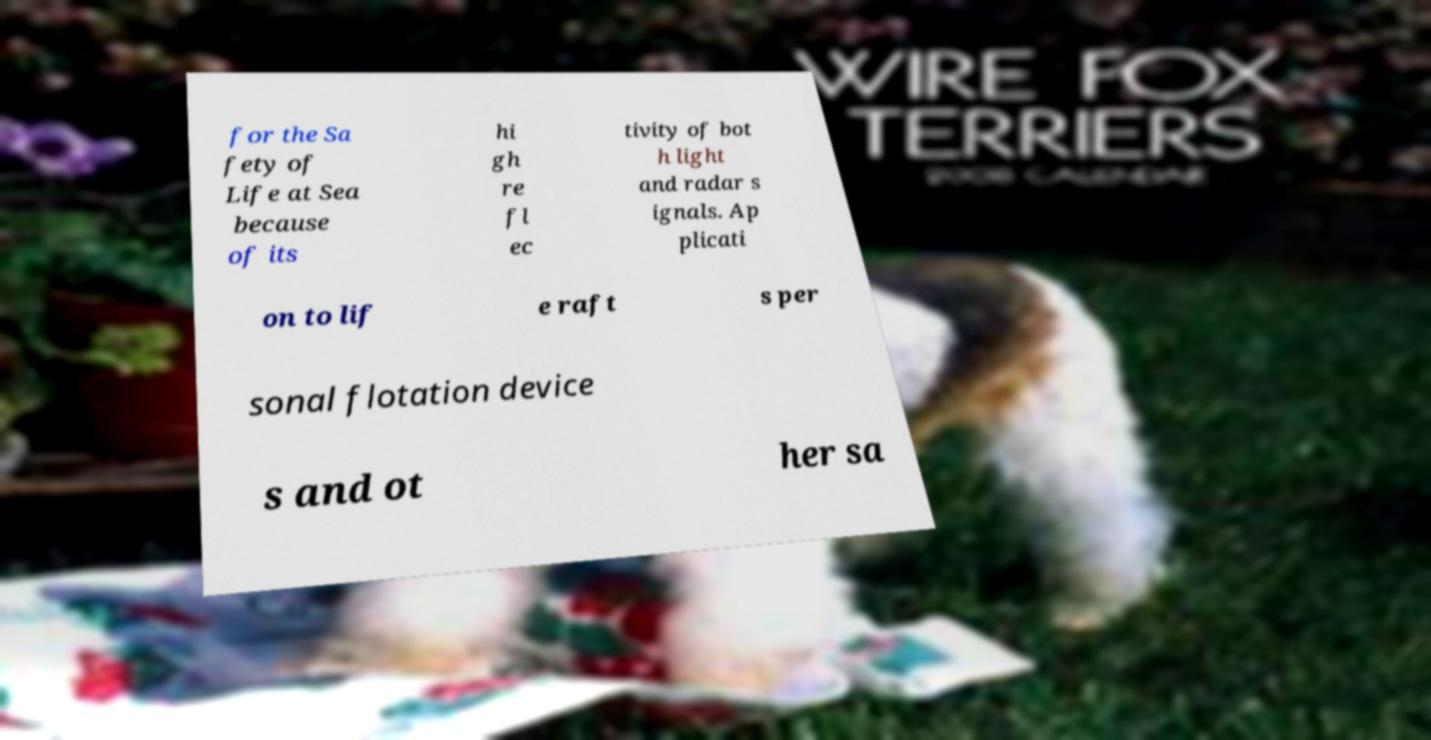Please read and relay the text visible in this image. What does it say? for the Sa fety of Life at Sea because of its hi gh re fl ec tivity of bot h light and radar s ignals. Ap plicati on to lif e raft s per sonal flotation device s and ot her sa 